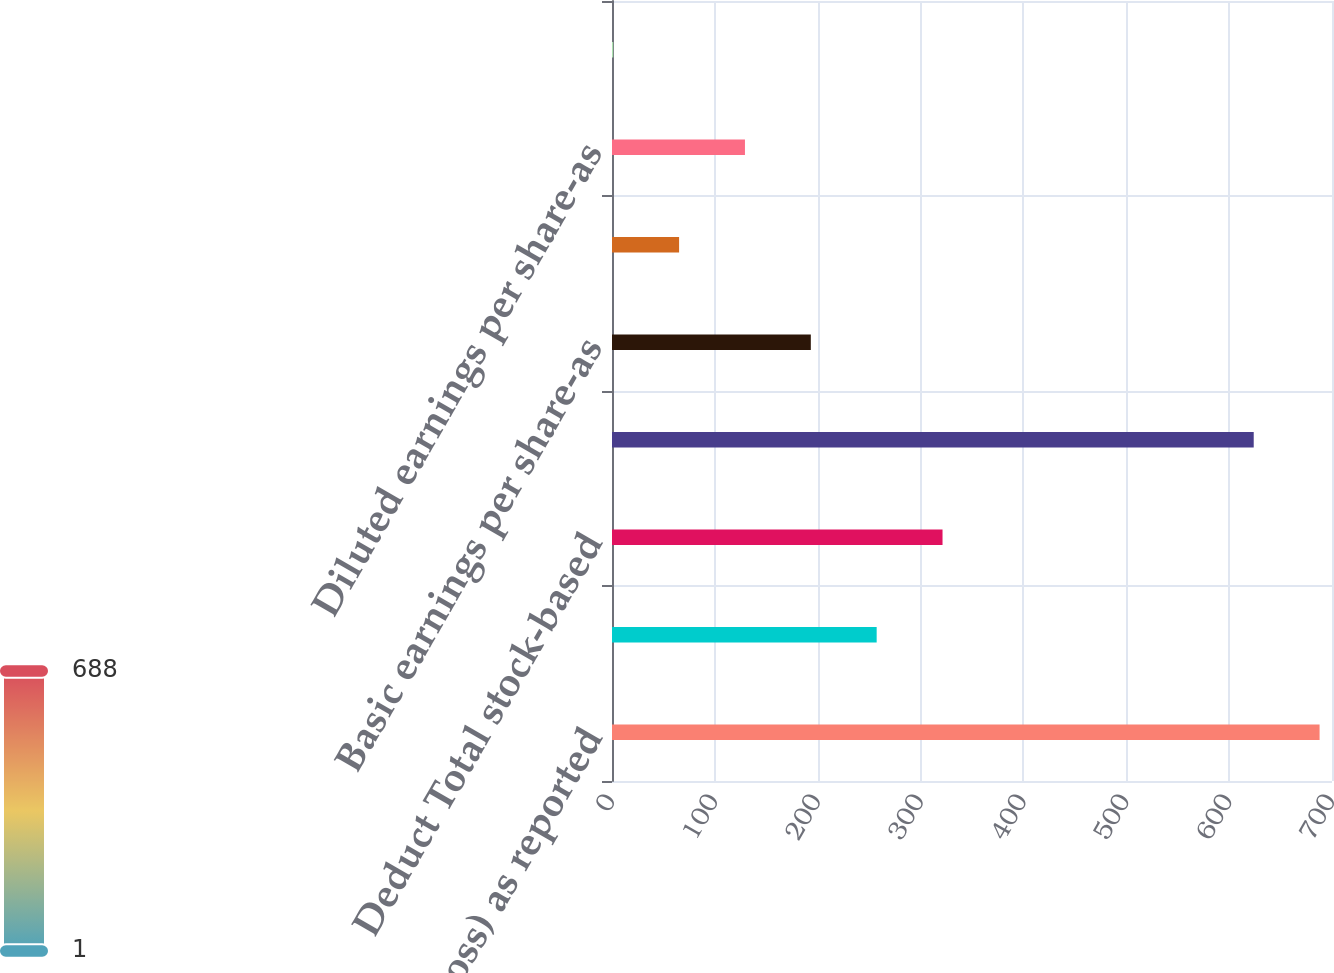Convert chart to OTSL. <chart><loc_0><loc_0><loc_500><loc_500><bar_chart><fcel>Net income (loss) as reported<fcel>Add Stock-based employee<fcel>Deduct Total stock-based<fcel>Pro forma net income (loss)<fcel>Basic earnings per share-as<fcel>Basic earnings per share-pro<fcel>Diluted earnings per share-as<fcel>Diluted earnings per share-pro<nl><fcel>687.93<fcel>257.32<fcel>321.35<fcel>623.9<fcel>193.29<fcel>65.23<fcel>129.26<fcel>1.2<nl></chart> 